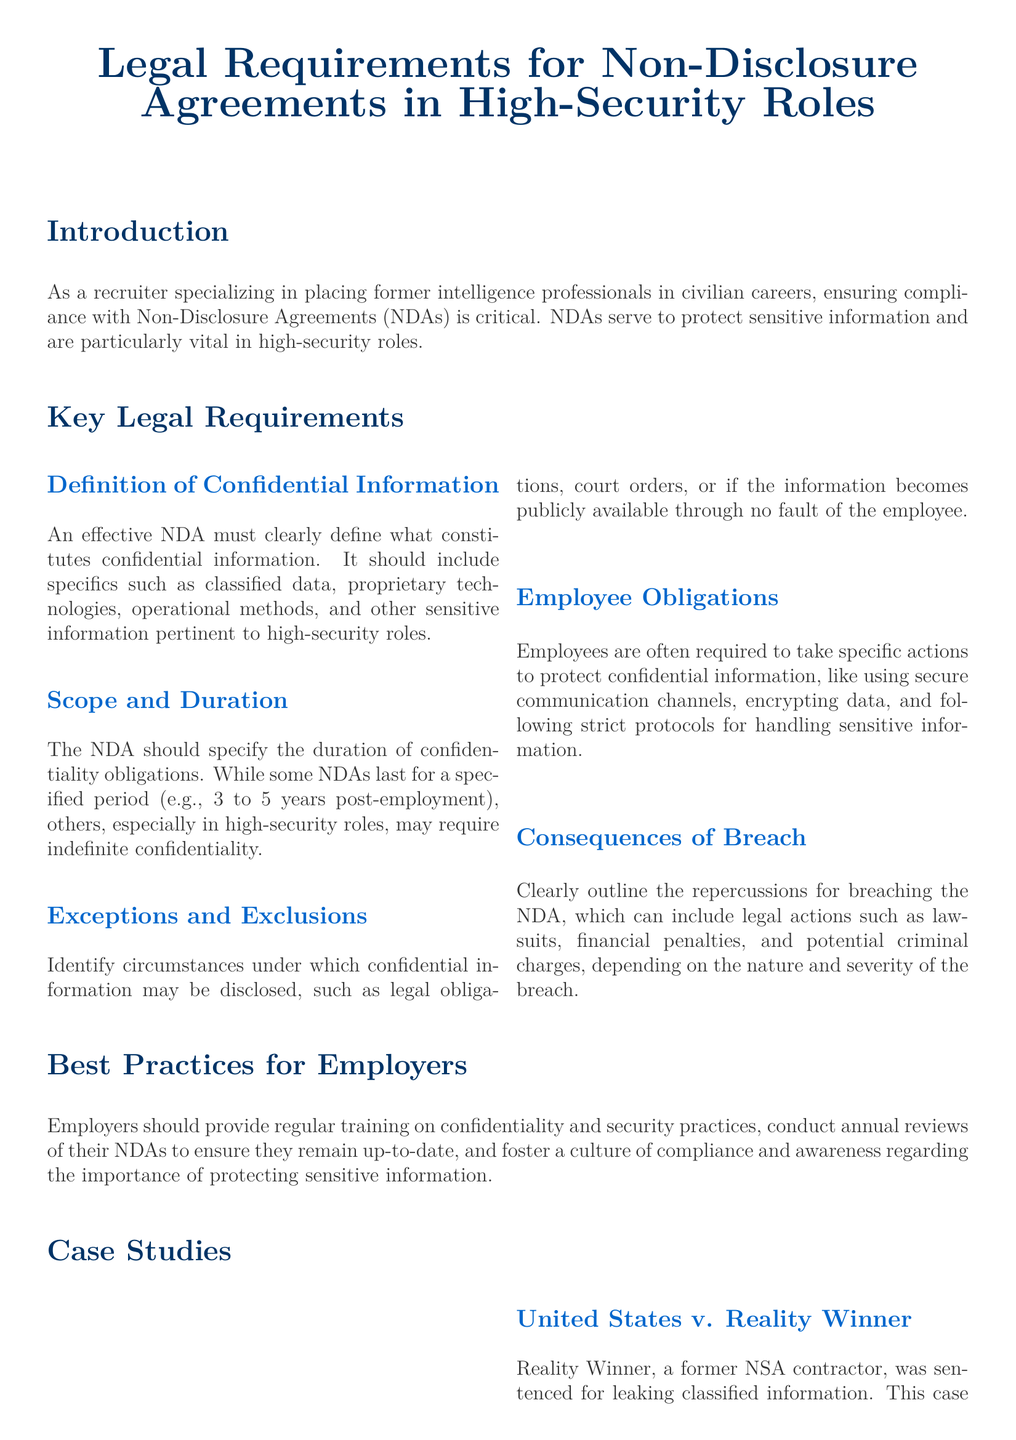What is the purpose of NDAs in high-security roles? NDAs serve to protect sensitive information and are particularly vital in high-security roles.
Answer: Protect sensitive information What is the duration of confidentiality obligations typically specified in NDAs? The NDA should specify the duration of confidentiality obligations, which can last for a specified period or may require indefinite confidentiality in high-security roles.
Answer: Indefinite confidentiality What obligations do employees have under an NDA? Employees are often required to take specific actions to protect confidential information.
Answer: Protect confidential information What case underscores the importance of understanding NDA obligations? The case of Reality Winner highlights the critical importance of ensuring employees understand their NDA obligations.
Answer: Reality Winner What are possible consequences of breaching an NDA? Clearly outlined repercussions can include legal actions such as lawsuits, financial penalties, and potential criminal charges.
Answer: Legal actions What is a key best practice for employers regarding NDAs? Employers should provide regular training on confidentiality and security practices.
Answer: Regular training What should an effective NDA include regarding confidential information? An effective NDA must clearly define what constitutes confidential information.
Answer: Definition of confidential information What exemplifies the need for robust NDAs in protecting proprietary technology? The Waymo v. Uber case involved the alleged theft of trade secrets by a former employee.
Answer: Waymo v. Uber 